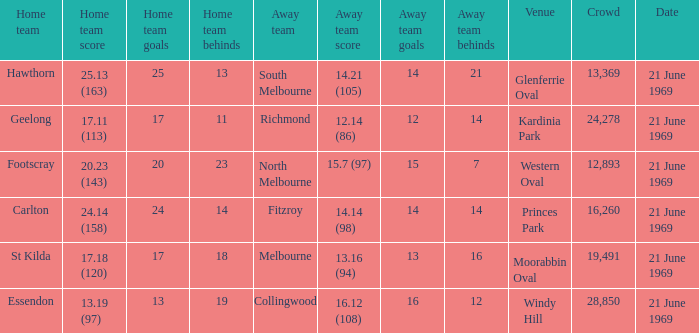What is Essendon's home team that has an away crowd size larger than 19,491? Collingwood. 